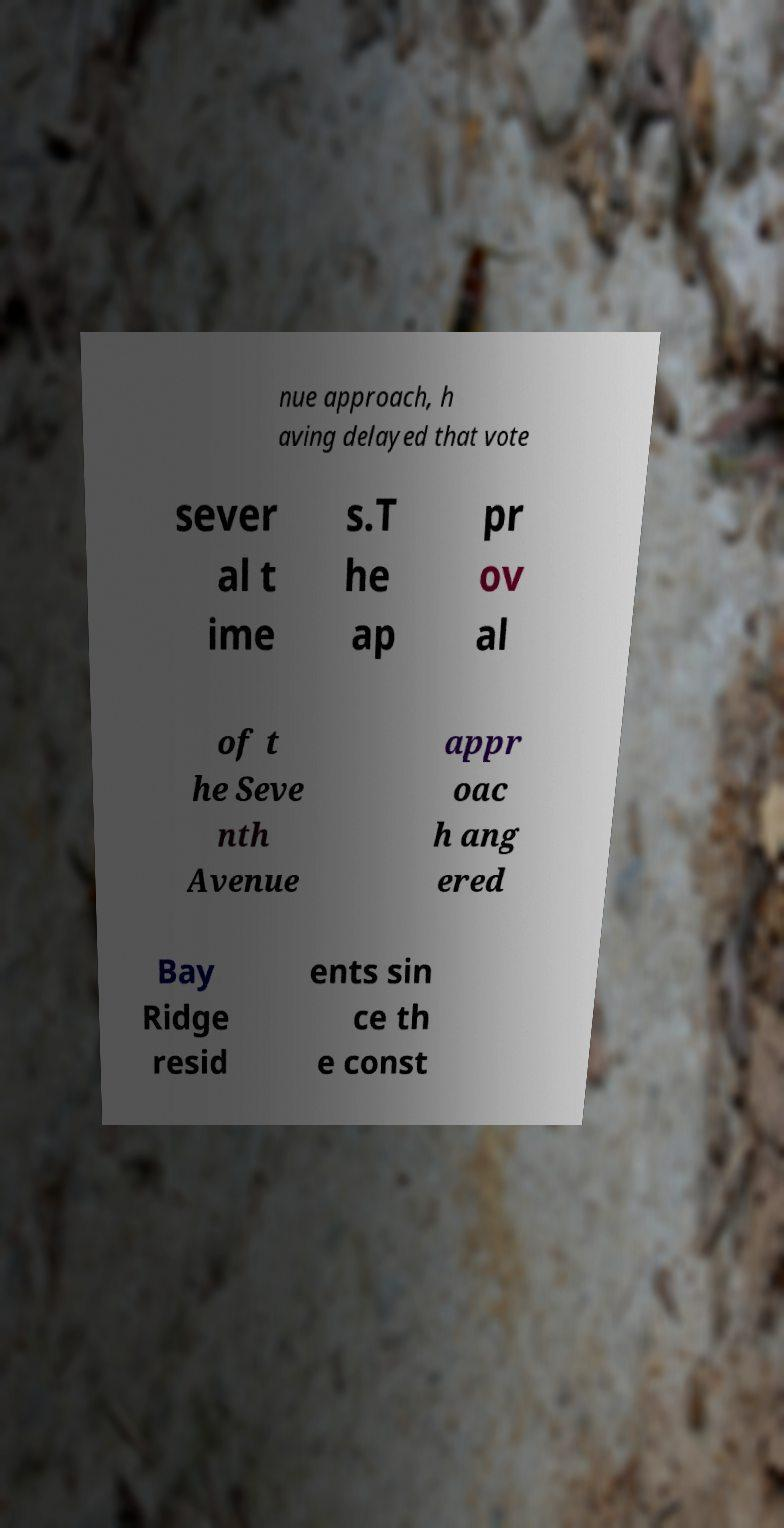For documentation purposes, I need the text within this image transcribed. Could you provide that? nue approach, h aving delayed that vote sever al t ime s.T he ap pr ov al of t he Seve nth Avenue appr oac h ang ered Bay Ridge resid ents sin ce th e const 